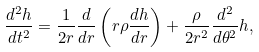<formula> <loc_0><loc_0><loc_500><loc_500>\frac { d ^ { 2 } h } { d t ^ { 2 } } = \frac { 1 } { 2 r } \frac { d } { d r } \left ( r \rho \frac { d h } { d r } \right ) + \frac { \rho } { 2 r ^ { 2 } } \frac { d ^ { 2 } } { d \theta ^ { 2 } } h ,</formula> 